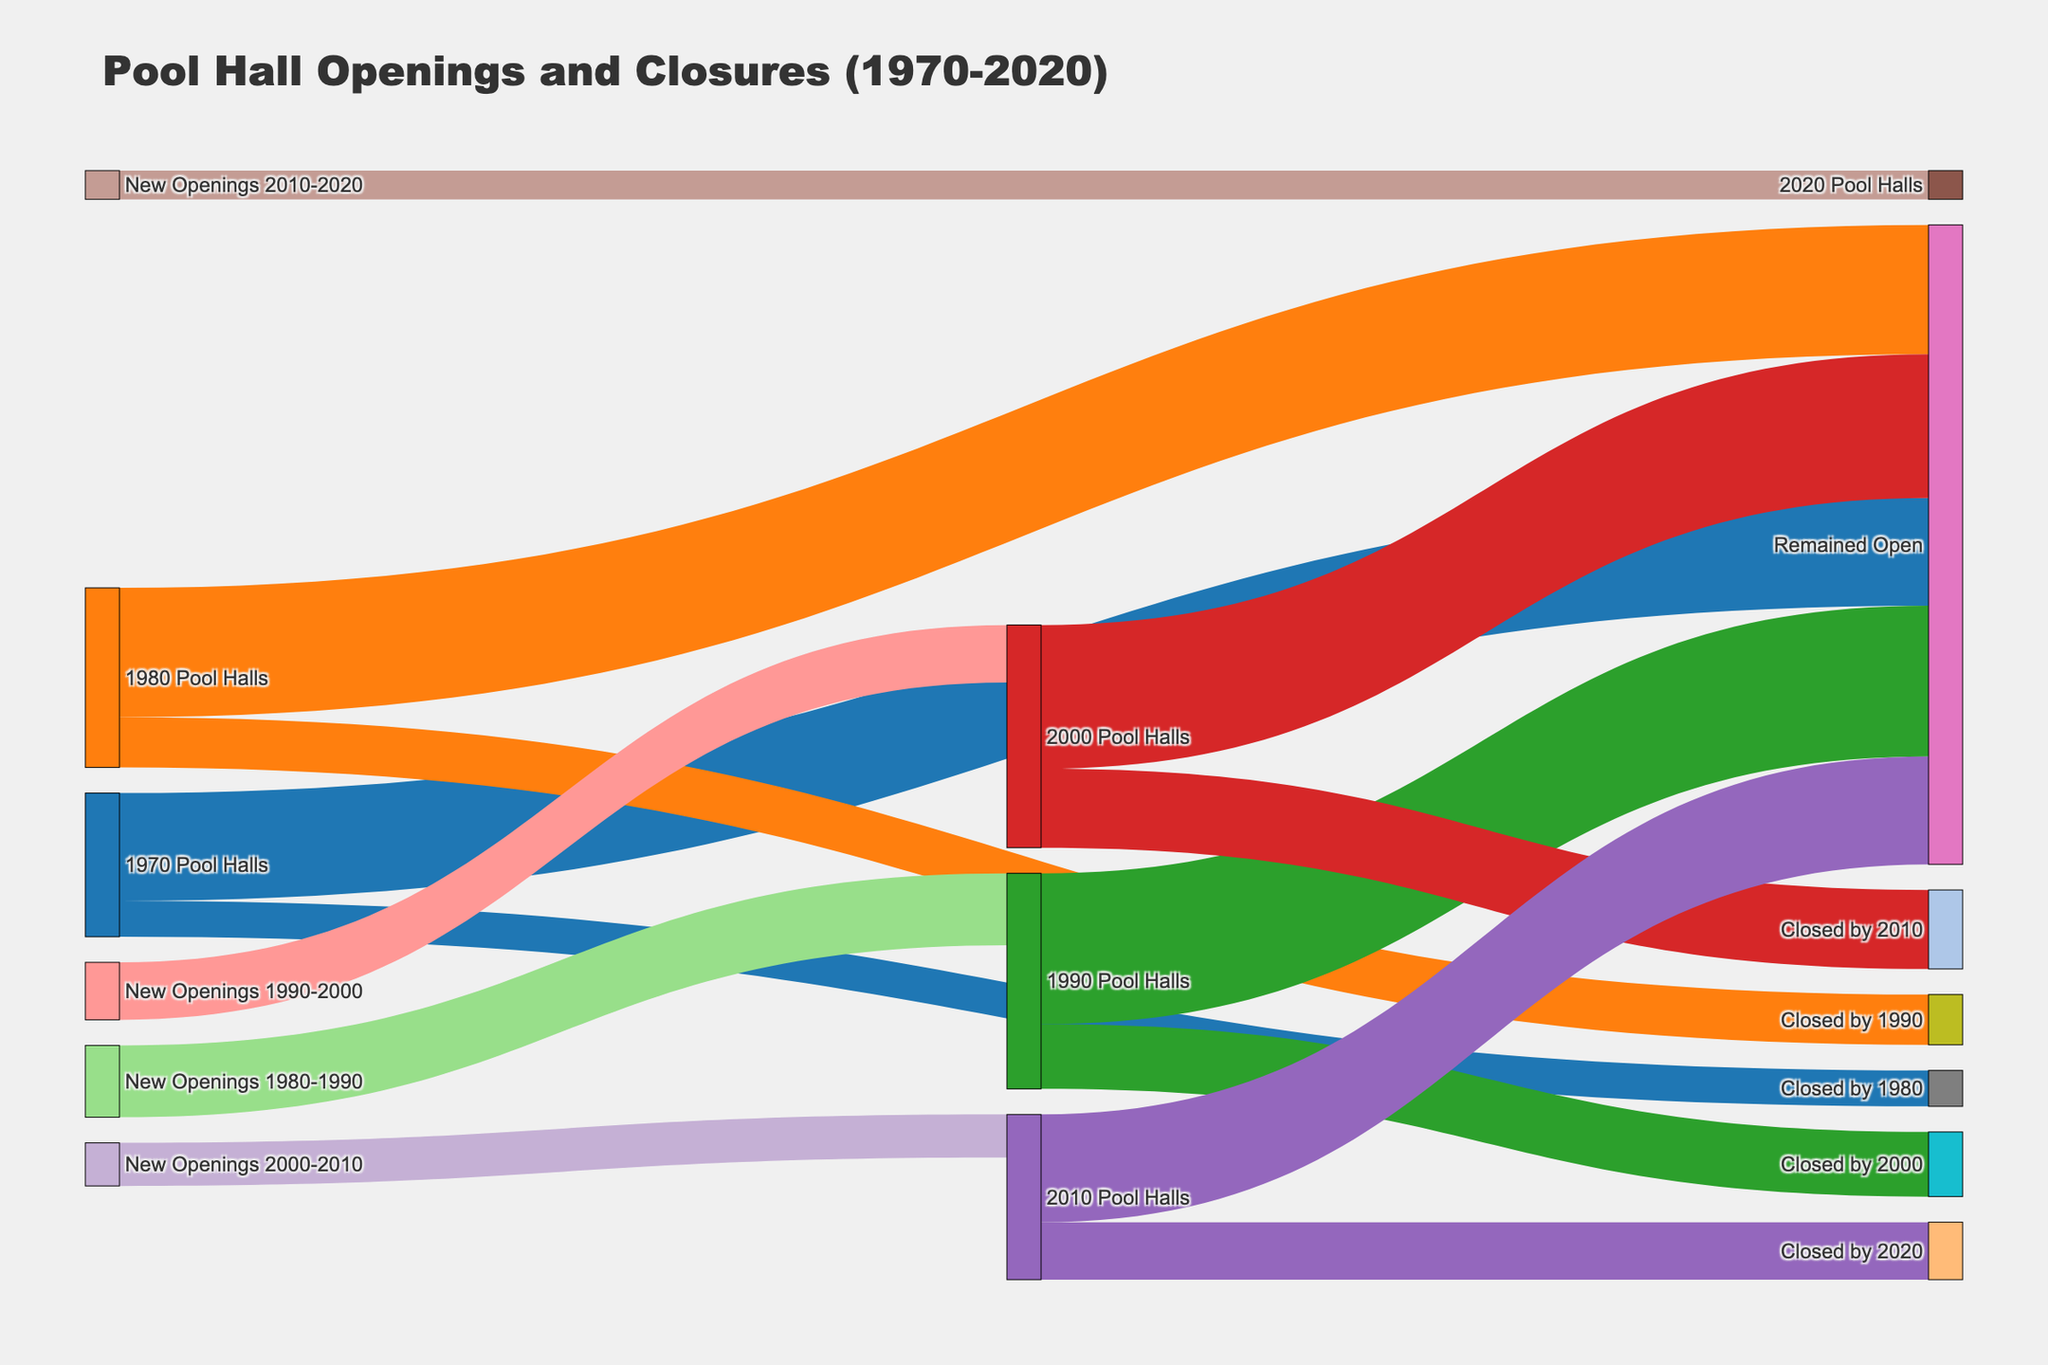What's the title of the figure? The title of the figure is displayed prominently at the top of the chart.
Answer: Pool Hall Openings and Closures (1970-2020) Which color represents the pool halls in 1970? In the legend or the chart, each category is associated with a specific color. The color for "1970 Pool Halls" is blue.
Answer: Blue How many pool halls remained open from 2010 to 2020? Locate the flow connected from "2010 Pool Halls" to "Remained Open". The value indicated on this link represents the number of pool halls that remained open from 2010 to 2020.
Answer: 150 How many pool halls were newly opened between 1980 and 1990? Find the node labeled "New Openings 1980-1990" and check the value connected to "1990 Pool Halls". This flow represents the new openings for that period.
Answer: 100 Compare the number of pool halls closed by 1990 and the number closed by 2000. Which period had more closures? Look at the values for the flows "Closed by 1990" and "Closed by 2000". Compare 70 (Closed by 1990) and 90 (Closed by 2000).
Answer: 1990-2000 What is the total number of pool halls that closed between 1970 and 1980? Check the value of the flow from "1970 Pool Halls" to "Closed by 1980". The number of closures between 1970 and 1980 is given as 50.
Answer: 50 How many pool halls opened between 2000 and 2010 and still remained open by 2020? First, find the flow "New Openings 2000-2010" and note its value (60). Then, trace the flow from "2010 Pool Halls" to "Remained Open" (150). Since not all 60 new openings might have remained open by 2020, further breakdown might not be directly visible topically, but the direct inference here is looking at new openings and their effects on totals. This more complex assessment might involve manually reconciling various nodes' balances.
Answer: Comprehensive balance (contextual, part of 150) What is the total number of pool halls in 1980 (including those that remained open from 1970 and new openings)? Add the pool halls that remained open from 1970 (150) plus new openings if mentioned separately in a node. Here, since there's continuity assumed from 1970 flows, it directly factors the 150 base.
Answer: 150 plus new openings (detail not explicitly disaggregated in node) 